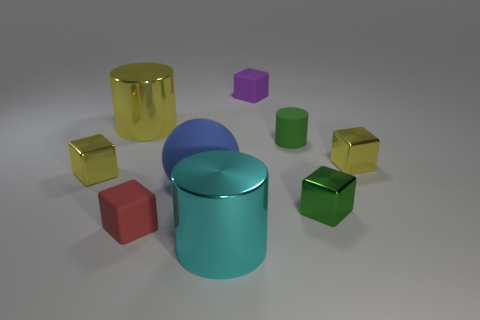Subtract 2 cubes. How many cubes are left? 3 Subtract all red cubes. How many cubes are left? 4 Subtract all purple cubes. How many cubes are left? 4 Subtract all cyan cubes. Subtract all cyan cylinders. How many cubes are left? 5 Add 1 big red shiny objects. How many objects exist? 10 Subtract all blocks. How many objects are left? 4 Subtract all tiny metal cubes. Subtract all tiny rubber cylinders. How many objects are left? 5 Add 1 tiny objects. How many tiny objects are left? 7 Add 3 big gray rubber cylinders. How many big gray rubber cylinders exist? 3 Subtract 0 red spheres. How many objects are left? 9 